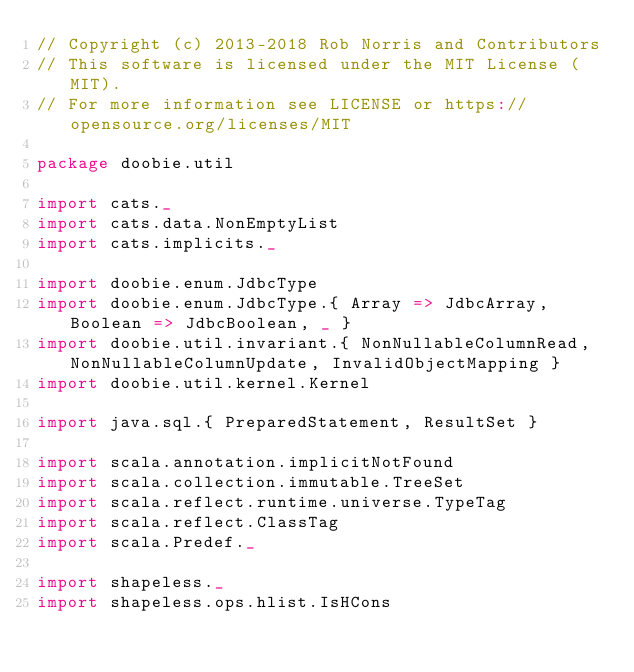Convert code to text. <code><loc_0><loc_0><loc_500><loc_500><_Scala_>// Copyright (c) 2013-2018 Rob Norris and Contributors
// This software is licensed under the MIT License (MIT).
// For more information see LICENSE or https://opensource.org/licenses/MIT

package doobie.util

import cats._
import cats.data.NonEmptyList
import cats.implicits._

import doobie.enum.JdbcType
import doobie.enum.JdbcType.{ Array => JdbcArray, Boolean => JdbcBoolean, _ }
import doobie.util.invariant.{ NonNullableColumnRead, NonNullableColumnUpdate, InvalidObjectMapping }
import doobie.util.kernel.Kernel

import java.sql.{ PreparedStatement, ResultSet }

import scala.annotation.implicitNotFound
import scala.collection.immutable.TreeSet
import scala.reflect.runtime.universe.TypeTag
import scala.reflect.ClassTag
import scala.Predef._

import shapeless._
import shapeless.ops.hlist.IsHCons
</code> 